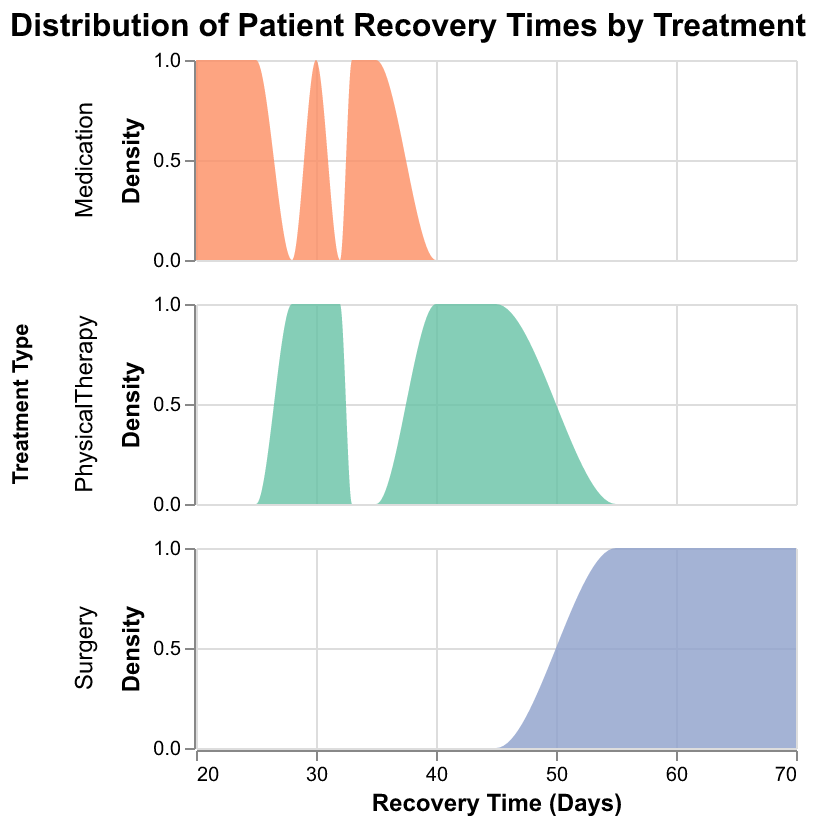What is the title of the plot? The title of the plot directly appears at the top of the figure as "Distribution of Patient Recovery Times by Treatment".
Answer: Distribution of Patient Recovery Times by Treatment Which treatment has the widest range of recovery times? The width of the density plot on the x-axis corresponds to the range of recovery times. Surgery spans from roughly 55 to 70 days, making it the widest range among the treatments.
Answer: Surgery How many treatments are compared in the figure? By observing the individual rows or facets for each treatment type, we see that there are three distinct groups: Physical Therapy, Medication, and Surgery.
Answer: Three What can you infer about the recovery time densities for 'Physical Therapy' and 'Surgery'? The plot suggests that the recovery times for Physical Therapy are concentrated in a tighter range around 28 to 45 days, while Surgery has a more spread-out density from 55 to 70 days, indicating more variable recovery times.
Answer: Physical Therapy is more concentrated; Surgery is more spread out Which treatment shows a single peak in its density plot? By examining the shape of the density curves, Physical Therapy and Surgery both show single peaks, while the density plot for Medication is less clear with multiple small peaks.
Answer: Physical Therapy and Surgery Compare the average recovery time across the three treatments. By evaluating the central density of each plot, Physical Therapy appears centered around 30-40 days, Medication around 25-30 days, and Surgery around 60-65 days. This suggests the average recovery time for Surgery is longer than the other two treatments.
Answer: Surgery has the longest average recovery time What is the approximate recovery time range for Medication treatment? The density plot for Medication spans from about 20 to 35 days on the x-axis.
Answer: 20 to 35 days Which treatment shows the highest recovery time in this plot? Surgery has the highest recovery time, with its density plotting upwards to 70 days.
Answer: Surgery Is there a significant overlap in the recovery times between Physical Therapy and Medication? By inspecting the x-axis ranges and the density curves, it is evident that there is some overlap between Physical Therapy and Medication, roughly around 28 to 35 days.
Answer: Yes If a patient is looking for the shortest recovery time, which treatment might they consider? Medication shows recovery times primarily between 20 to 35 days, which is the shortest range compared to Physical Therapy and Surgery.
Answer: Medication 